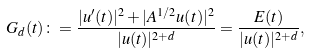<formula> <loc_0><loc_0><loc_500><loc_500>G _ { d } ( t ) \colon = \frac { | u ^ { \prime } ( t ) | ^ { 2 } + | A ^ { 1 / 2 } u ( t ) | ^ { 2 } } { | u ( t ) | ^ { 2 + d } } = \frac { E ( t ) } { | u ( t ) | ^ { 2 + d } } ,</formula> 